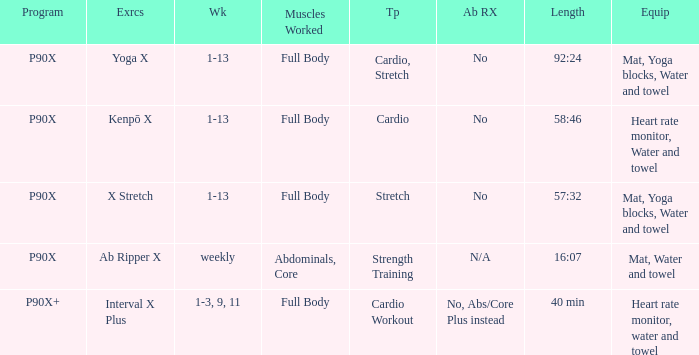What is the exercise when the equipment is heart rate monitor, water and towel? Kenpō X, Interval X Plus. 